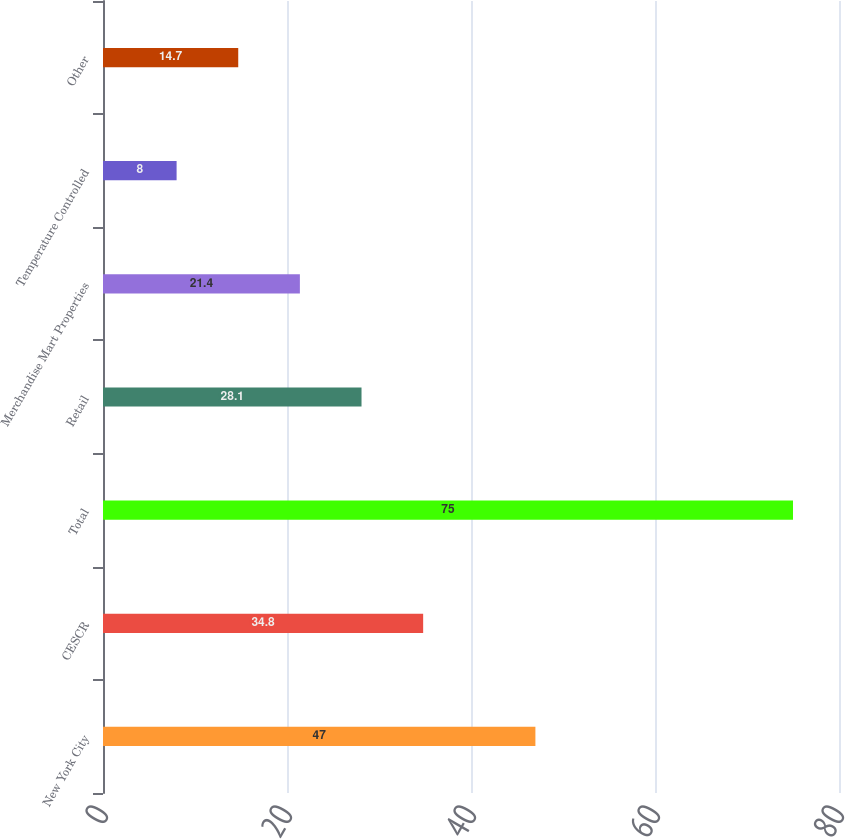Convert chart. <chart><loc_0><loc_0><loc_500><loc_500><bar_chart><fcel>New York City<fcel>CESCR<fcel>Total<fcel>Retail<fcel>Merchandise Mart Properties<fcel>Temperature Controlled<fcel>Other<nl><fcel>47<fcel>34.8<fcel>75<fcel>28.1<fcel>21.4<fcel>8<fcel>14.7<nl></chart> 